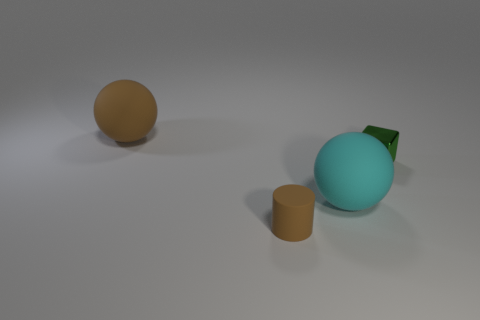Subtract all red blocks. Subtract all green cylinders. How many blocks are left? 1 Add 1 red things. How many objects exist? 5 Subtract all blocks. How many objects are left? 3 Subtract all big purple metallic cubes. Subtract all brown rubber cylinders. How many objects are left? 3 Add 1 small matte cylinders. How many small matte cylinders are left? 2 Add 1 brown rubber cylinders. How many brown rubber cylinders exist? 2 Subtract 0 cyan blocks. How many objects are left? 4 